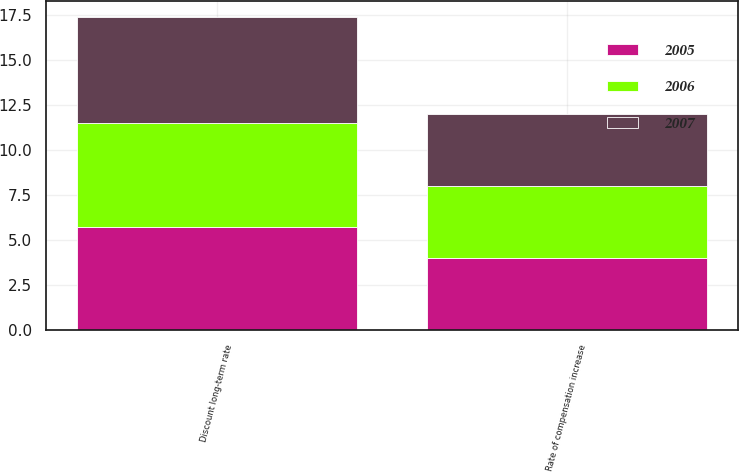<chart> <loc_0><loc_0><loc_500><loc_500><stacked_bar_chart><ecel><fcel>Discount long-term rate<fcel>Rate of compensation increase<nl><fcel>2007<fcel>5.9<fcel>4<nl><fcel>2006<fcel>5.75<fcel>4<nl><fcel>2005<fcel>5.75<fcel>4<nl></chart> 